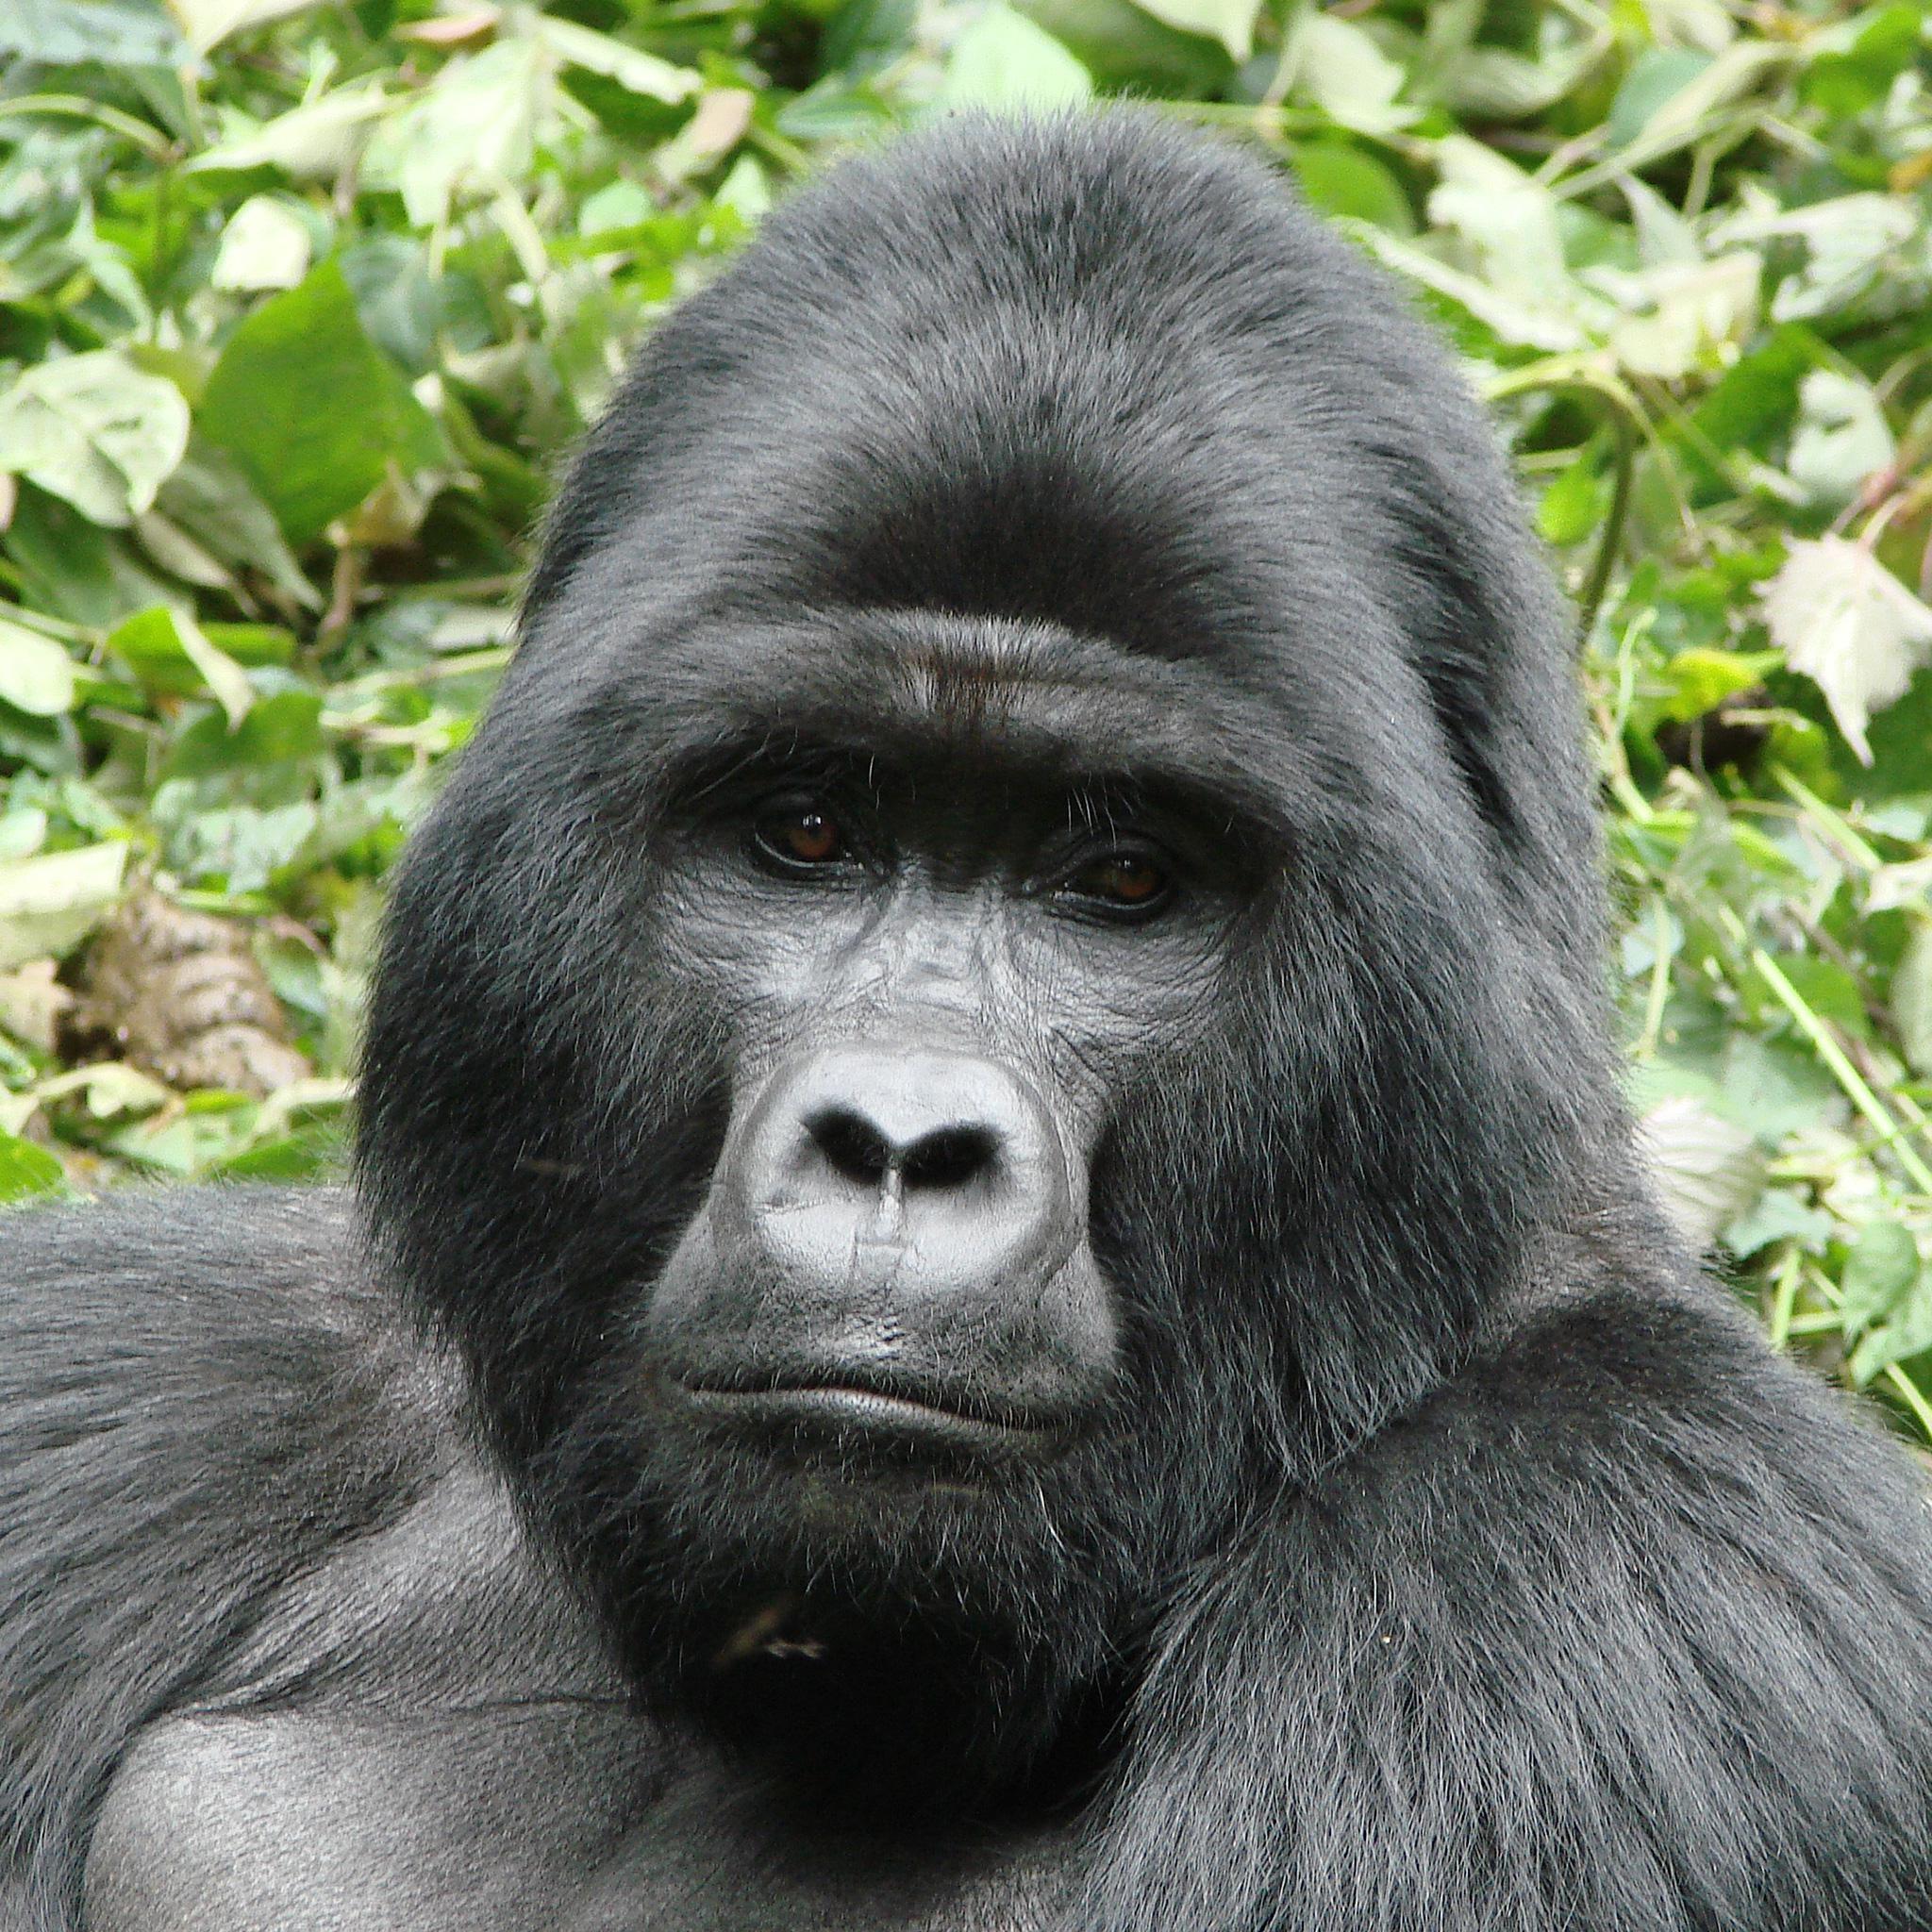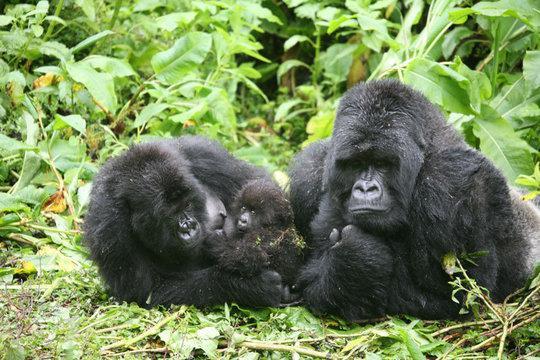The first image is the image on the left, the second image is the image on the right. Assess this claim about the two images: "Baby gorilla is visible in the right image.". Correct or not? Answer yes or no. Yes. The first image is the image on the left, the second image is the image on the right. Considering the images on both sides, is "There are two adult gorillas and one baby gorilla in one of the images." valid? Answer yes or no. Yes. 